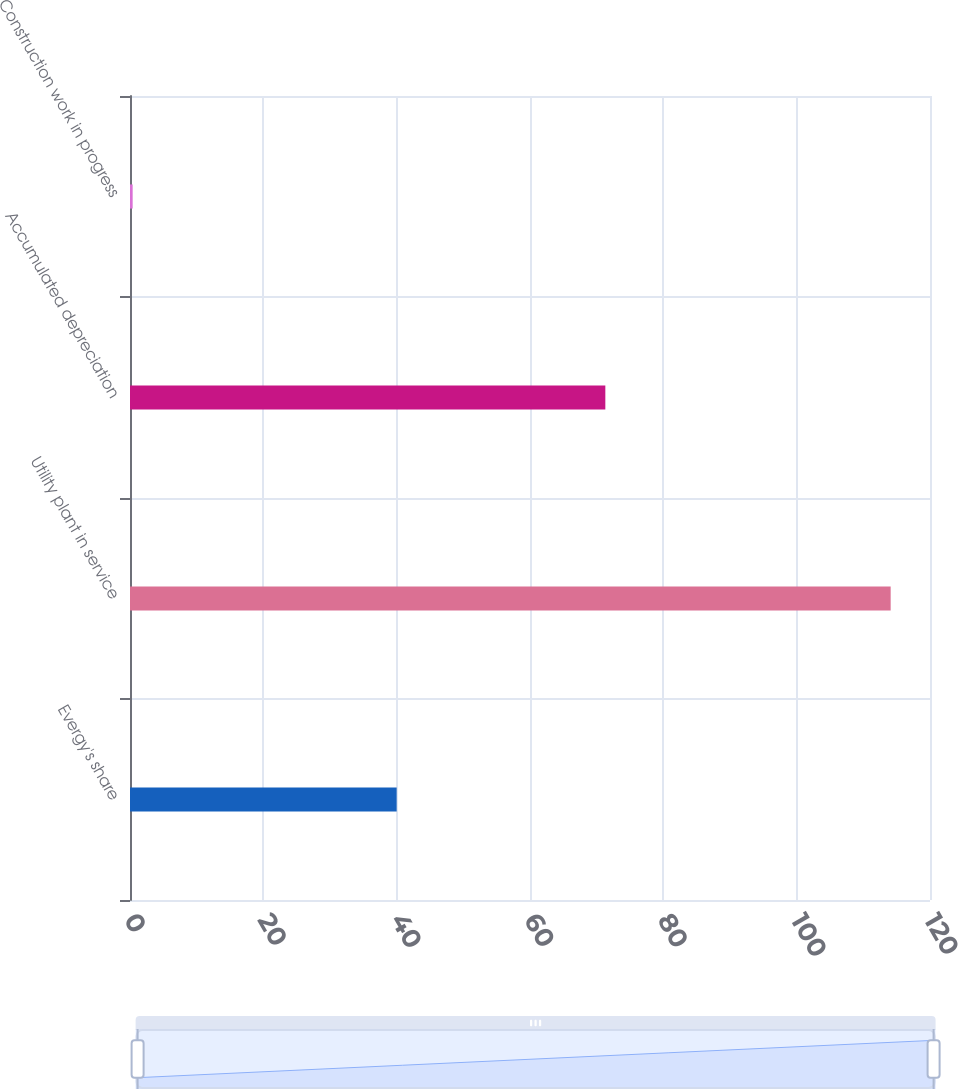Convert chart to OTSL. <chart><loc_0><loc_0><loc_500><loc_500><bar_chart><fcel>Evergy's share<fcel>Utility plant in service<fcel>Accumulated depreciation<fcel>Construction work in progress<nl><fcel>40<fcel>114.1<fcel>71.3<fcel>0.4<nl></chart> 